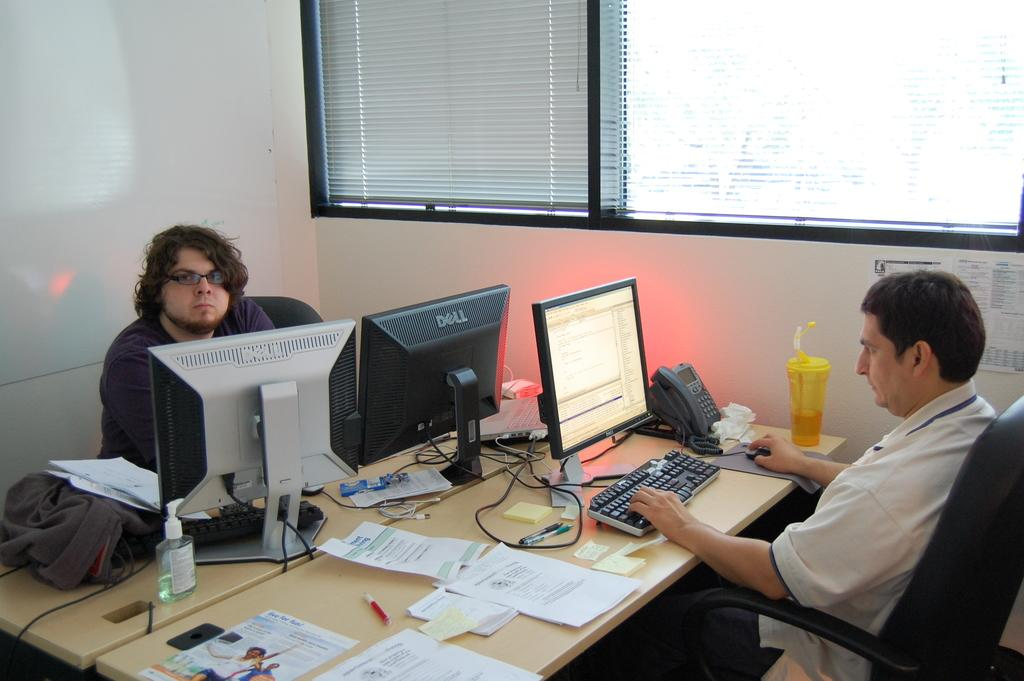<image>
Provide a brief description of the given image. Some guys are typing on Dell computers at their desks. 